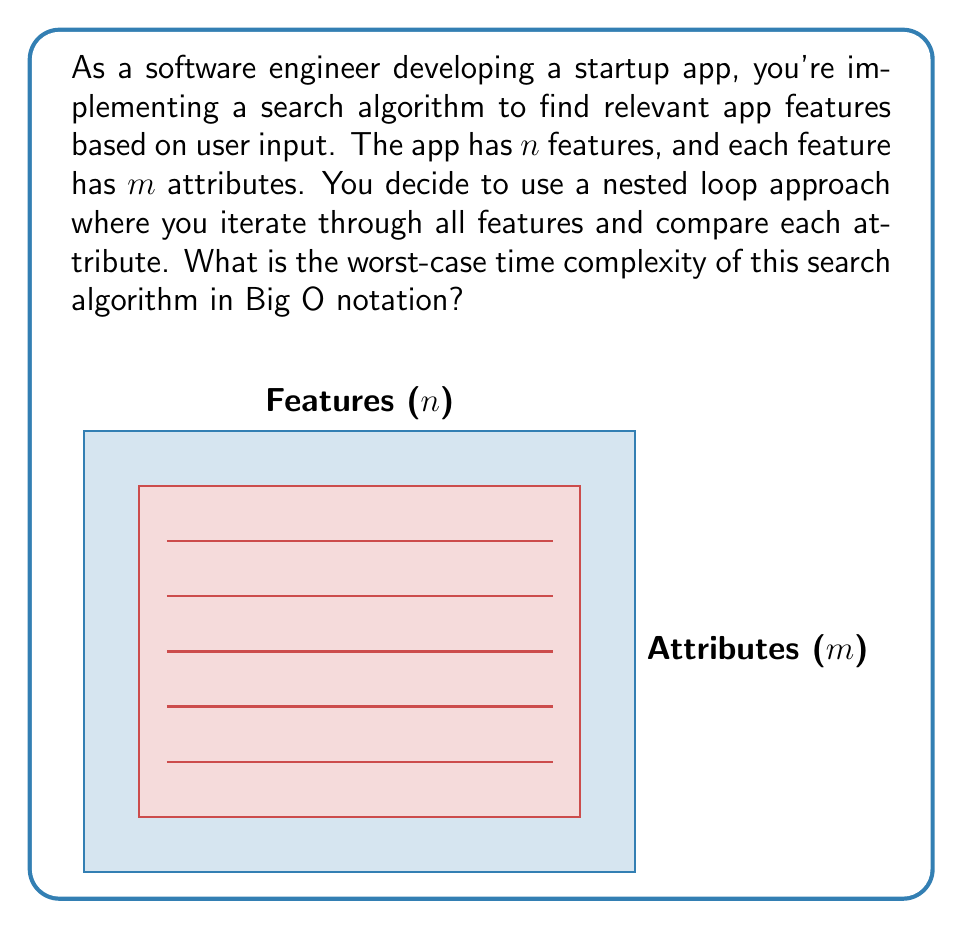Provide a solution to this math problem. To determine the worst-case time complexity, let's analyze the algorithm step-by-step:

1) The outer loop iterates through all $n$ features of the app.

2) For each feature, the inner loop compares all $m$ attributes.

3) The comparison operation inside the inner loop is assumed to take constant time, $O(1)$.

4) The structure of the algorithm can be represented as:

   ```
   for each feature (n times):
       for each attribute (m times):
           compare attribute (constant time)
   ```

5) The inner loop runs $m$ times for each iteration of the outer loop.

6) The outer loop runs $n$ times.

7) Therefore, the total number of operations is $n * m$.

8) In Big O notation, we express this as $O(n * m)$.

This quadratic time complexity indicates that as the number of features ($n$) and attributes ($m$) increases, the search time will grow significantly, which could be a concern for app performance as the feature set expands.
Answer: $O(n * m)$ 